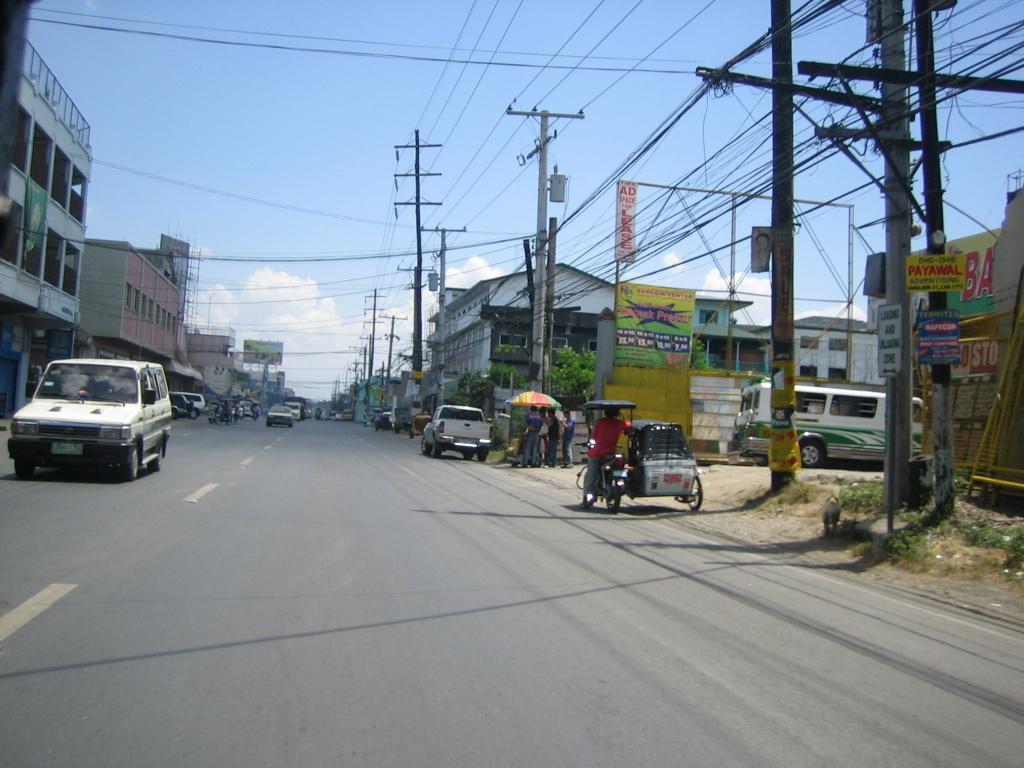How would you summarize this image in a sentence or two? In this picture there are houses on the right and left side of the image and there are poles and posters in the image, there are cars in the image, there is a tree on the right side of the image, it seems to be the road side view. 